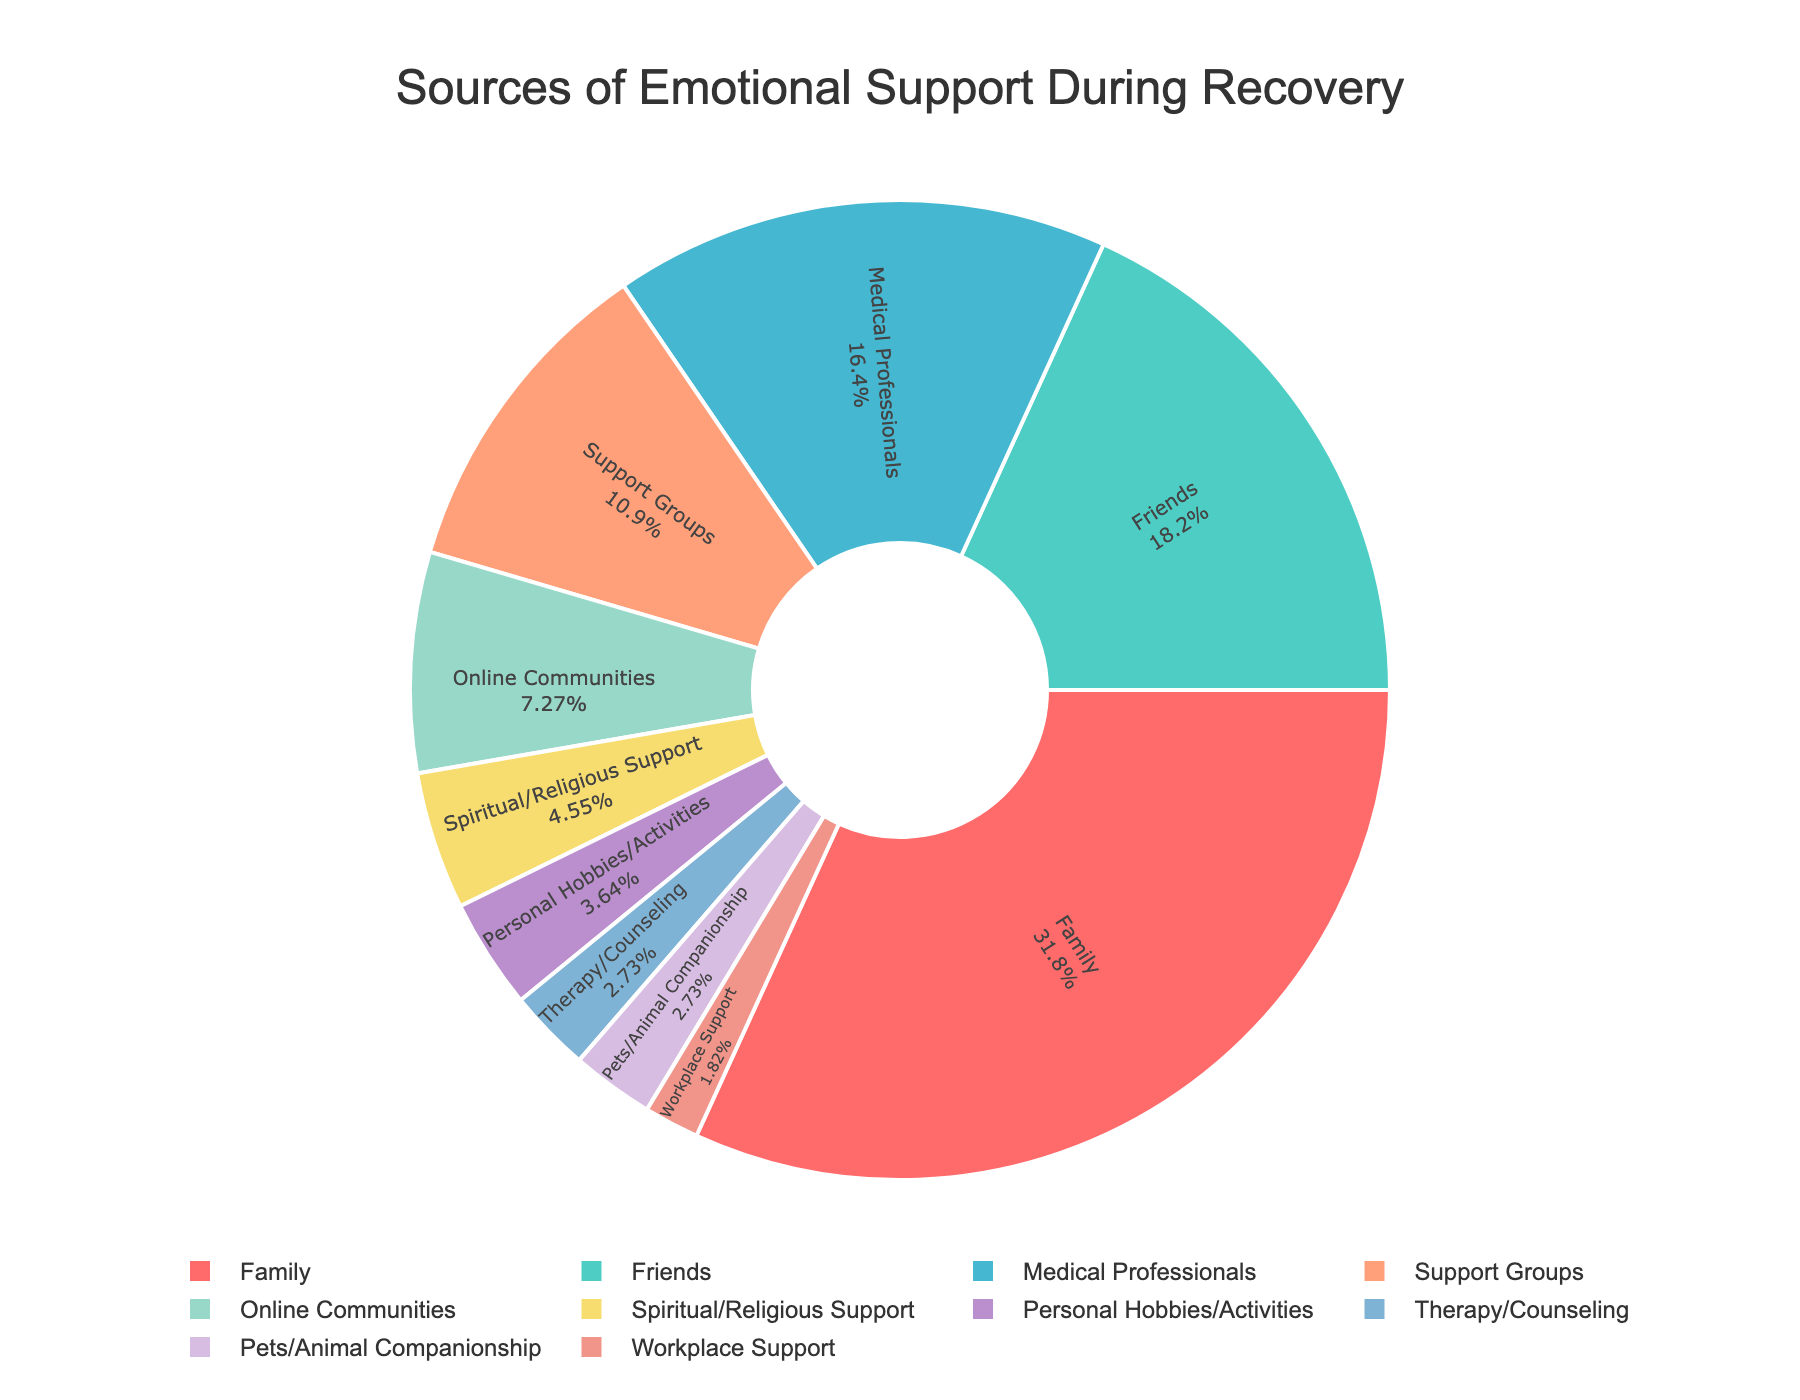What is the most common source of emotional support during recovery? The largest percentage slice in the pie chart represents the most common source. Family, at 35%, is the largest slice.
Answer: Family Which source of emotional support provides less support than Friends but more than Online Communities? Friends provide 20% support and Online Communities provide 8%. The source between these is Medical Professionals at 18%.
Answer: Medical Professionals What are the combined contributions of Pets/Animal Companionship, Therapy/Counseling, and Workplace Support? Sum the percentages: 3% (Pets/Animal Companionship) + 3% (Therapy/Counseling) + 2% (Workplace Support) = 8%.
Answer: 8% How does the support from Spiritual/Religious Support compare to that from Personal Hobbies/Activities? Spiritual/Religious Support provides 5%, while Personal Hobbies/Activities provide 4%. Hence, Spiritual/Religious Support is greater.
Answer: Greater Is the support provided by Medical Professionals higher or lower than the combined support from Online Communities and Therapy/Counseling? Medical Professionals provide 18%. Combined support from Online Communities (8%) and Therapy/Counseling (3%) is 11%, which is less than 18%.
Answer: Higher Among Family, Friends, and Support Groups, which source provides the least support? Compare the percentages: Family (35%), Friends (20%), Support Groups (12%). Support Groups provide the least support.
Answer: Support Groups Which source of emotional support is represented by the orange slice in the pie chart? The visual attribute "orange slice" corresponds to the Support Groups section of the pie chart with a 12% contribution.
Answer: Support Groups What are the combined contributions of the two largest sources of emotional support? The largest sources are Family (35%) and Friends (20%). Adding their contributions: 35% + 20% = 55%.
Answer: 55% How does the support from Family compare to the combined support from Friends, Medical Professionals, and Support Groups? Family provides 35%. Combined support from Friends (20%), Medical Professionals (18%), and Support Groups (12%) is 50%, which is greater than 35%.
Answer: Less 